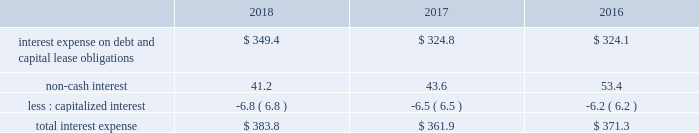Gain on business divestitures and impairments , net we strive to have a number one or number two market position in each of the markets we serve , or have a clear path on how we will achieve a leading market position over time .
Where we cannot establish a leading market position , or where operations are not generating acceptable returns , we may decide to divest certain assets and reallocate resources to other markets .
Asset or business divestitures could result in gains , losses or asset impairment charges that may be material to our results of operations in a given period .
During 2018 , we recorded a net gain on business divestitures , net of asset impairments of $ 44.9 million .
During 2017 , we recorded a net gain on business divestitures , net of asset impairments of $ 27.1 million .
We also recorded a gain on business divestitures of $ 6.8 million due to the transfer of ownership of the landfill gas collection and control system and the remaining post-closure and environmental liabilities associated with one of our divested landfills .
During 2016 , we recorded a charge to earnings of $ 4.6 million primarily related to environmental costs associated with one of our divested landfills .
During 2016 , we also recorded a net gain related to a business divestiture of $ 4.7 million .
Restructuring charges in january 2018 , we eliminated certain positions following the consolidation of select back-office functions , including but not limited to the integration of our national accounts support functions into our existing corporate support functions .
These changes include a reduction in administrative staffing and the closure of certain office locations .
During 2018 , we incurred restructuring charges of $ 26.4 million that primarily consisted of severance and other employee termination benefits , the closure of offices with non-cancelable lease agreements , and the redesign of our back-office functions and upgrades to certain of our software systems .
We paid $ 24.7 million during 2018 related to these restructuring efforts .
In january 2016 , we realigned our field support functions by combining our three regions into two field groups , consolidating our areas and streamlining select operational support roles at our phoenix headquarters .
Additionally , in the second quarter of 2016 , we began the redesign of our back-office functions as well as the consolidation of over 100 customer service locations into three customer resource centers .
The redesign of our back-office functions and upgrades to certain of our software systems continued into 2018 .
During the years ended december 31 , 2017 and 2016 , we incurred $ 17.6 million and $ 40.7 million of restructuring charges , respectively , that primarily consisted of severance and other employee termination benefits , transition costs , relocation benefits , and the closure of offices with lease agreements with non-cancelable terms .
The savings realized from these restructuring efforts have been reinvested in our customer-focused programs and initiatives .
Interest expense the table provides the components of interest expense , including accretion of debt discounts and accretion of discounts primarily associated with environmental and risk insurance liabilities assumed in acquisitions ( in millions of dollars ) : .
Total interest expense for 2018 increased compared to 2017 primarily due to the increase in debt outstanding during the period and higher interest rates on floating rate debt .
Total interest expense for 2017 decreased .
What is the percentage of the restructuring charges paid to those incurred in 2018? 
Rationale: the percent of the amount paid to the amount incurred is the division of the amount paid by the amount incurred
Computations: (24.7 / 26.4)
Answer: 0.93561. 